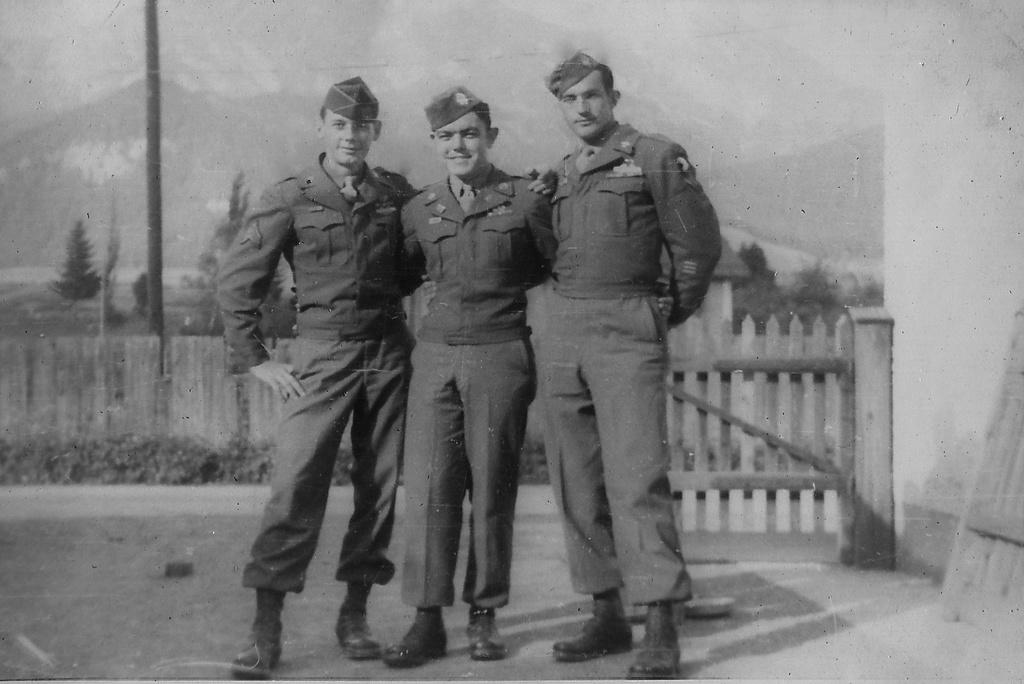How many people are in the image? There is a group of people in the image. What are the people doing in the image? The people are standing and smiling. What can be seen in the background of the image? There is fencing and trees in the image. What is the color scheme of the image? The image is in black and white. What type of hat is the person wearing in the image? There is no hat visible in the image; the people are not wearing any headwear. What ingredients are used to make the stew in the image? There is no stew present in the image; it features a group of people standing and smiling. 